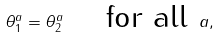<formula> <loc_0><loc_0><loc_500><loc_500>\theta _ { 1 } ^ { a } = \theta _ { 2 } ^ { a } \quad \text { for all } a ,</formula> 